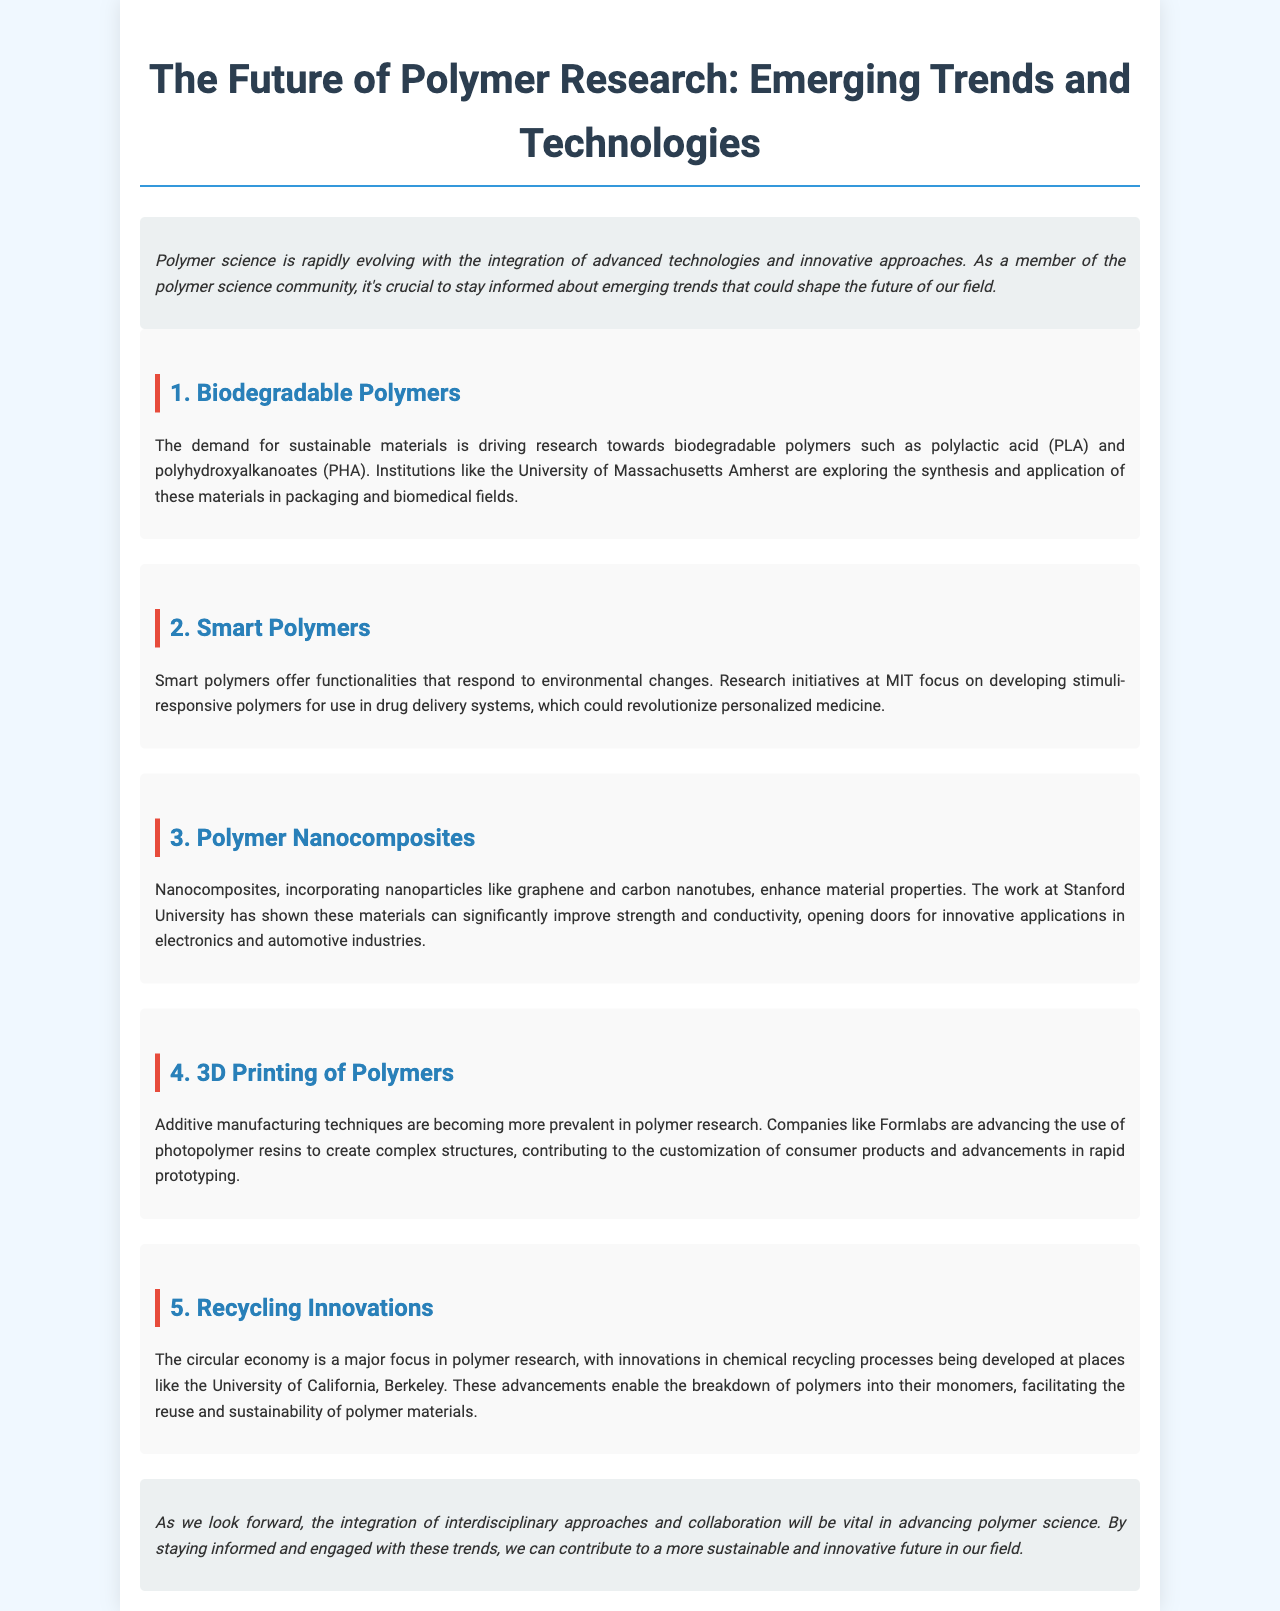What is the first trend mentioned in the brochure? The first trend discussed in the brochure is titled "Biodegradable Polymers."
Answer: Biodegradable Polymers Which institution focuses on biodegradable polymers? The University of Massachusetts Amherst is mentioned as exploring biodegradable polymers.
Answer: University of Massachusetts Amherst What type of polymers are being developed at MIT? The document states that MIT is developing "stimuli-responsive polymers."
Answer: stimuli-responsive polymers What is the primary focus of research at Stanford University? Stanford University's research primarily focuses on polymer nanocomposites incorporating nanoparticles.
Answer: polymer nanocomposites Which company is advancing the use of photopolymer resins? Formlabs is the company mentioned that is advancing the use of photopolymer resins.
Answer: Formlabs What major area does recycling innovations contribute to in polymer research? The document highlights that recycling innovations contribute to the "circular economy."
Answer: circular economy How do the emerging trends in polymer research aim to contribute to the future? The trends aim to contribute to a more sustainable and innovative future in polymer science.
Answer: sustainable and innovative future What is the key factor for advancing polymer science in the future? The brochure emphasizes "integration of interdisciplinary approaches and collaboration" as key factors.
Answer: integration of interdisciplinary approaches and collaboration 